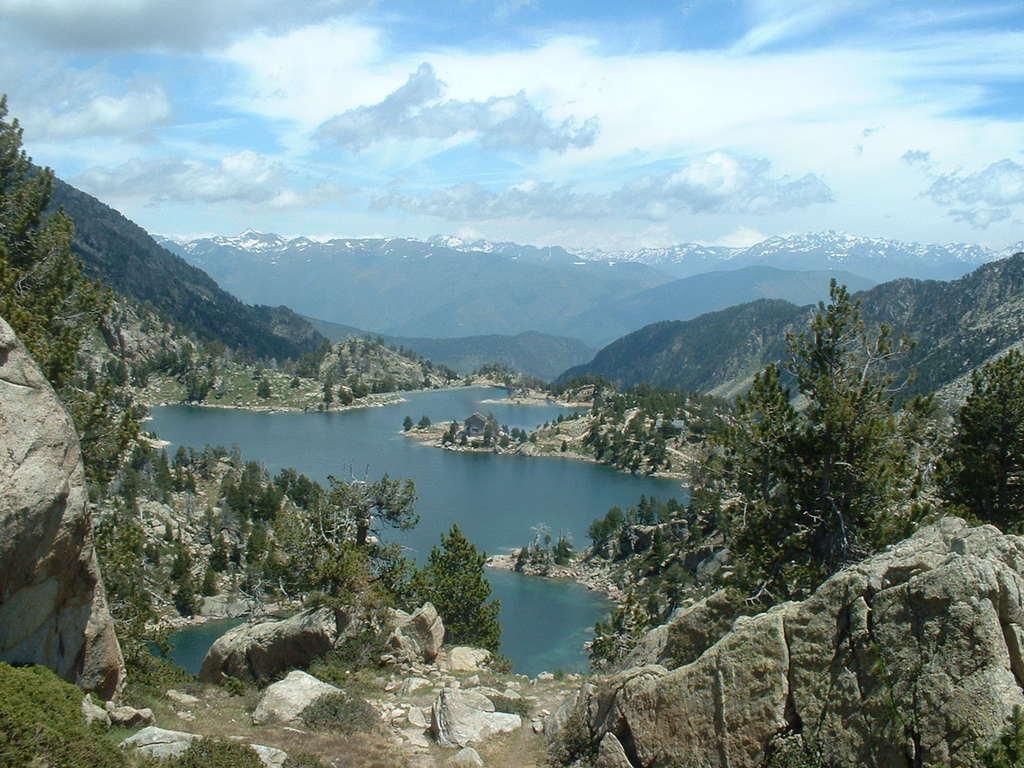Describe this image in one or two sentences. This is the picture of a mountain. In this image there are mountains and trees. At the top there is sky and there are clouds. At the bottom there is water. At the back there is snow on the mountain. 